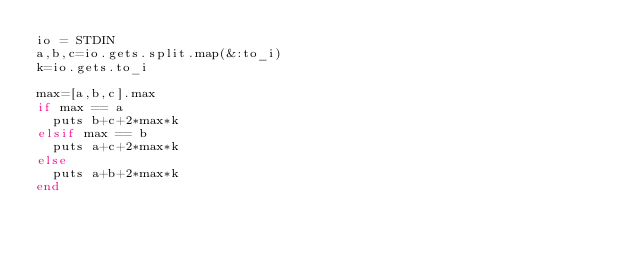<code> <loc_0><loc_0><loc_500><loc_500><_Ruby_>io = STDIN
a,b,c=io.gets.split.map(&:to_i)
k=io.gets.to_i

max=[a,b,c].max
if max == a
  puts b+c+2*max*k
elsif max == b
  puts a+c+2*max*k
else
  puts a+b+2*max*k
end
</code> 